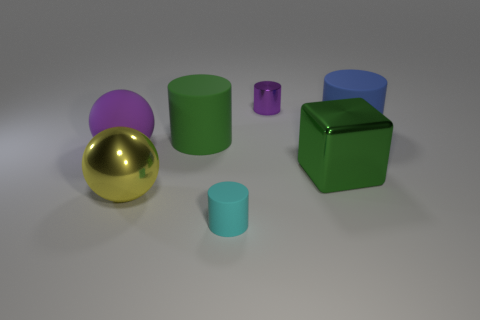Does the small metal object have the same color as the large rubber object that is left of the large green cylinder?
Give a very brief answer. Yes. What size is the thing that is the same color as the metallic cylinder?
Make the answer very short. Large. Is there a large object of the same color as the shiny block?
Give a very brief answer. Yes. Is the number of large matte cylinders greater than the number of things?
Provide a succinct answer. No. What number of blue rubber objects are the same size as the cyan rubber object?
Provide a succinct answer. 0. There is a object that is the same color as the metal cylinder; what is its shape?
Your response must be concise. Sphere. What number of things are tiny things in front of the green block or large blue matte cylinders?
Provide a succinct answer. 2. Is the number of large green things less than the number of big red metallic cubes?
Your response must be concise. No. What is the shape of the purple thing that is made of the same material as the cyan thing?
Your answer should be very brief. Sphere. Are there any big metallic spheres to the right of the cube?
Your response must be concise. No. 